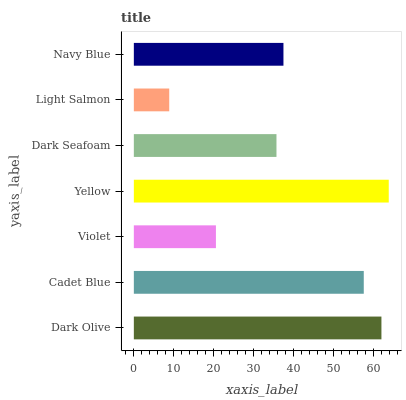Is Light Salmon the minimum?
Answer yes or no. Yes. Is Yellow the maximum?
Answer yes or no. Yes. Is Cadet Blue the minimum?
Answer yes or no. No. Is Cadet Blue the maximum?
Answer yes or no. No. Is Dark Olive greater than Cadet Blue?
Answer yes or no. Yes. Is Cadet Blue less than Dark Olive?
Answer yes or no. Yes. Is Cadet Blue greater than Dark Olive?
Answer yes or no. No. Is Dark Olive less than Cadet Blue?
Answer yes or no. No. Is Navy Blue the high median?
Answer yes or no. Yes. Is Navy Blue the low median?
Answer yes or no. Yes. Is Light Salmon the high median?
Answer yes or no. No. Is Yellow the low median?
Answer yes or no. No. 